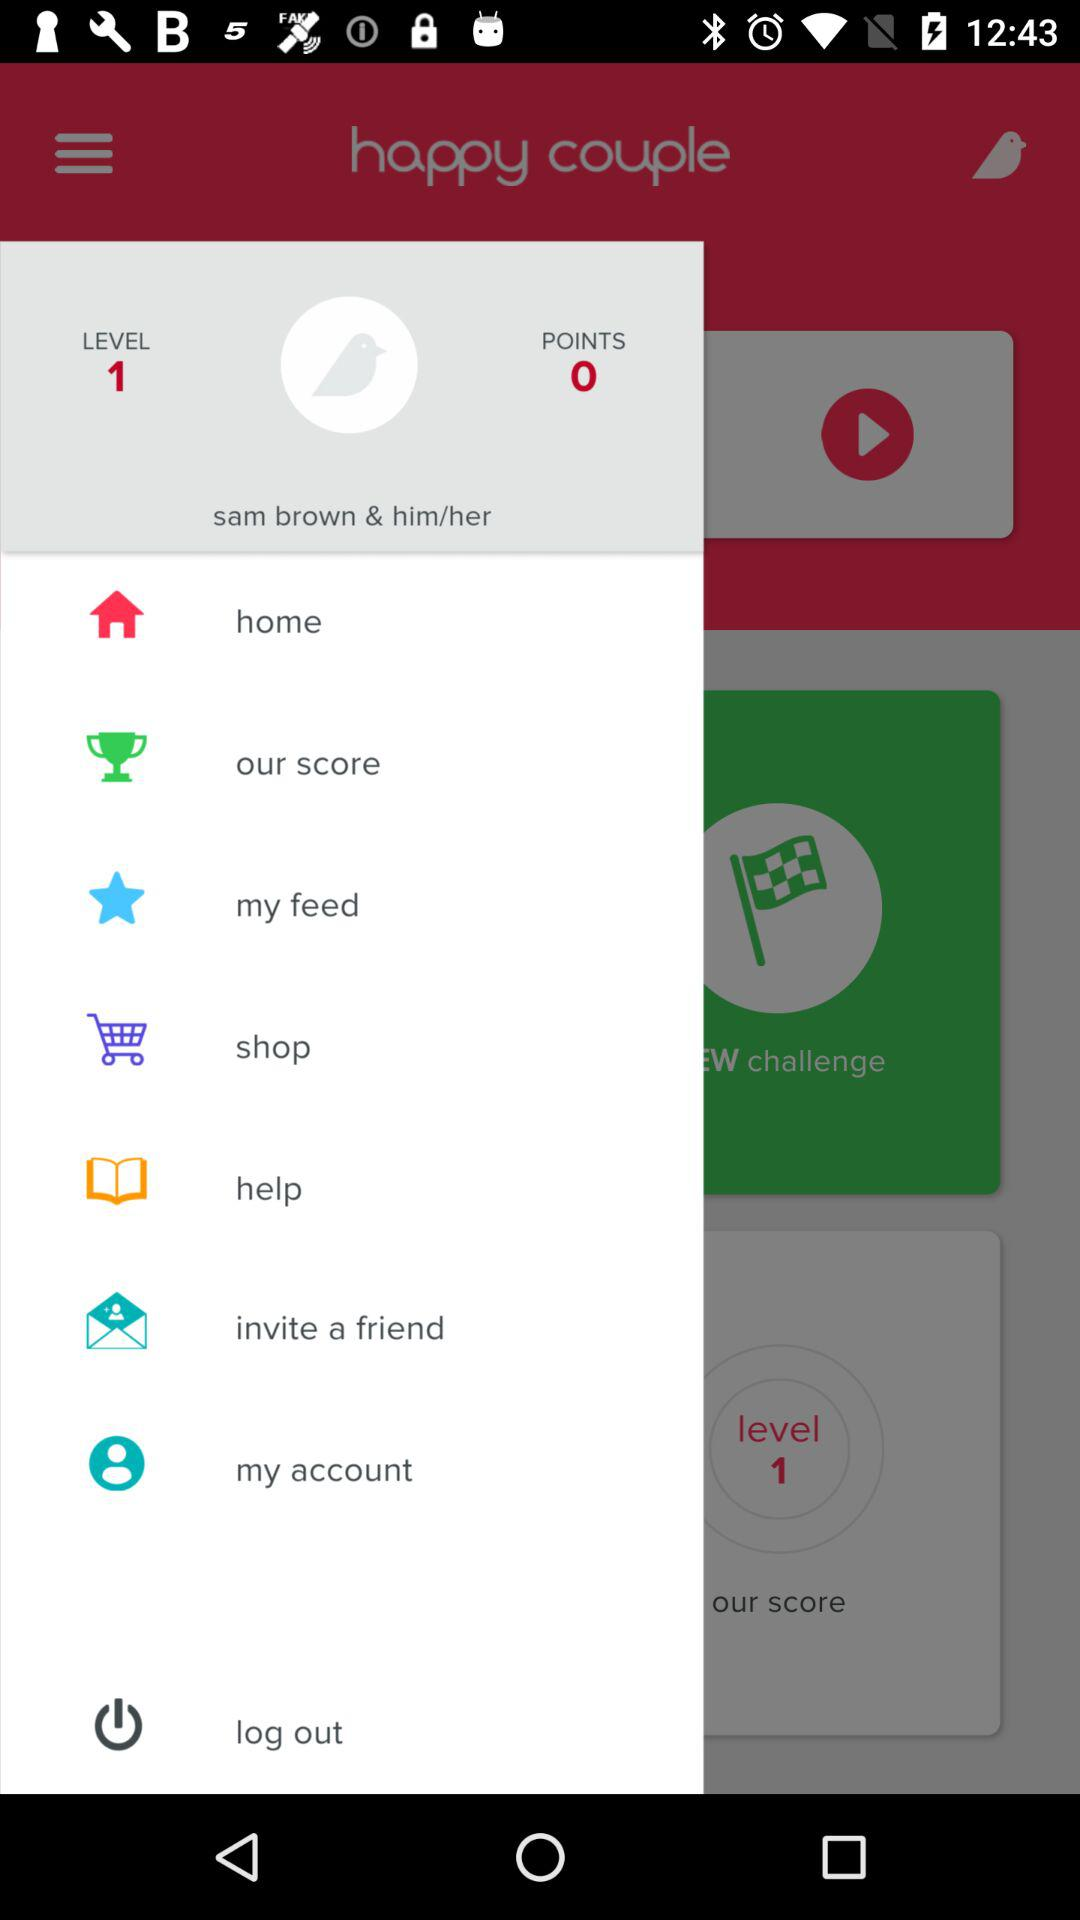How many points does the user have right now? The user has 0 points right now. 